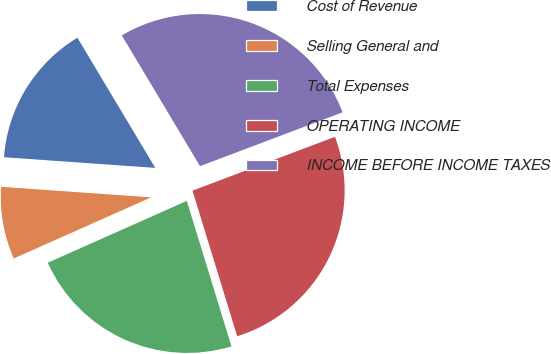<chart> <loc_0><loc_0><loc_500><loc_500><pie_chart><fcel>Cost of Revenue<fcel>Selling General and<fcel>Total Expenses<fcel>OPERATING INCOME<fcel>INCOME BEFORE INCOME TAXES<nl><fcel>15.3%<fcel>7.78%<fcel>23.08%<fcel>26.01%<fcel>27.83%<nl></chart> 